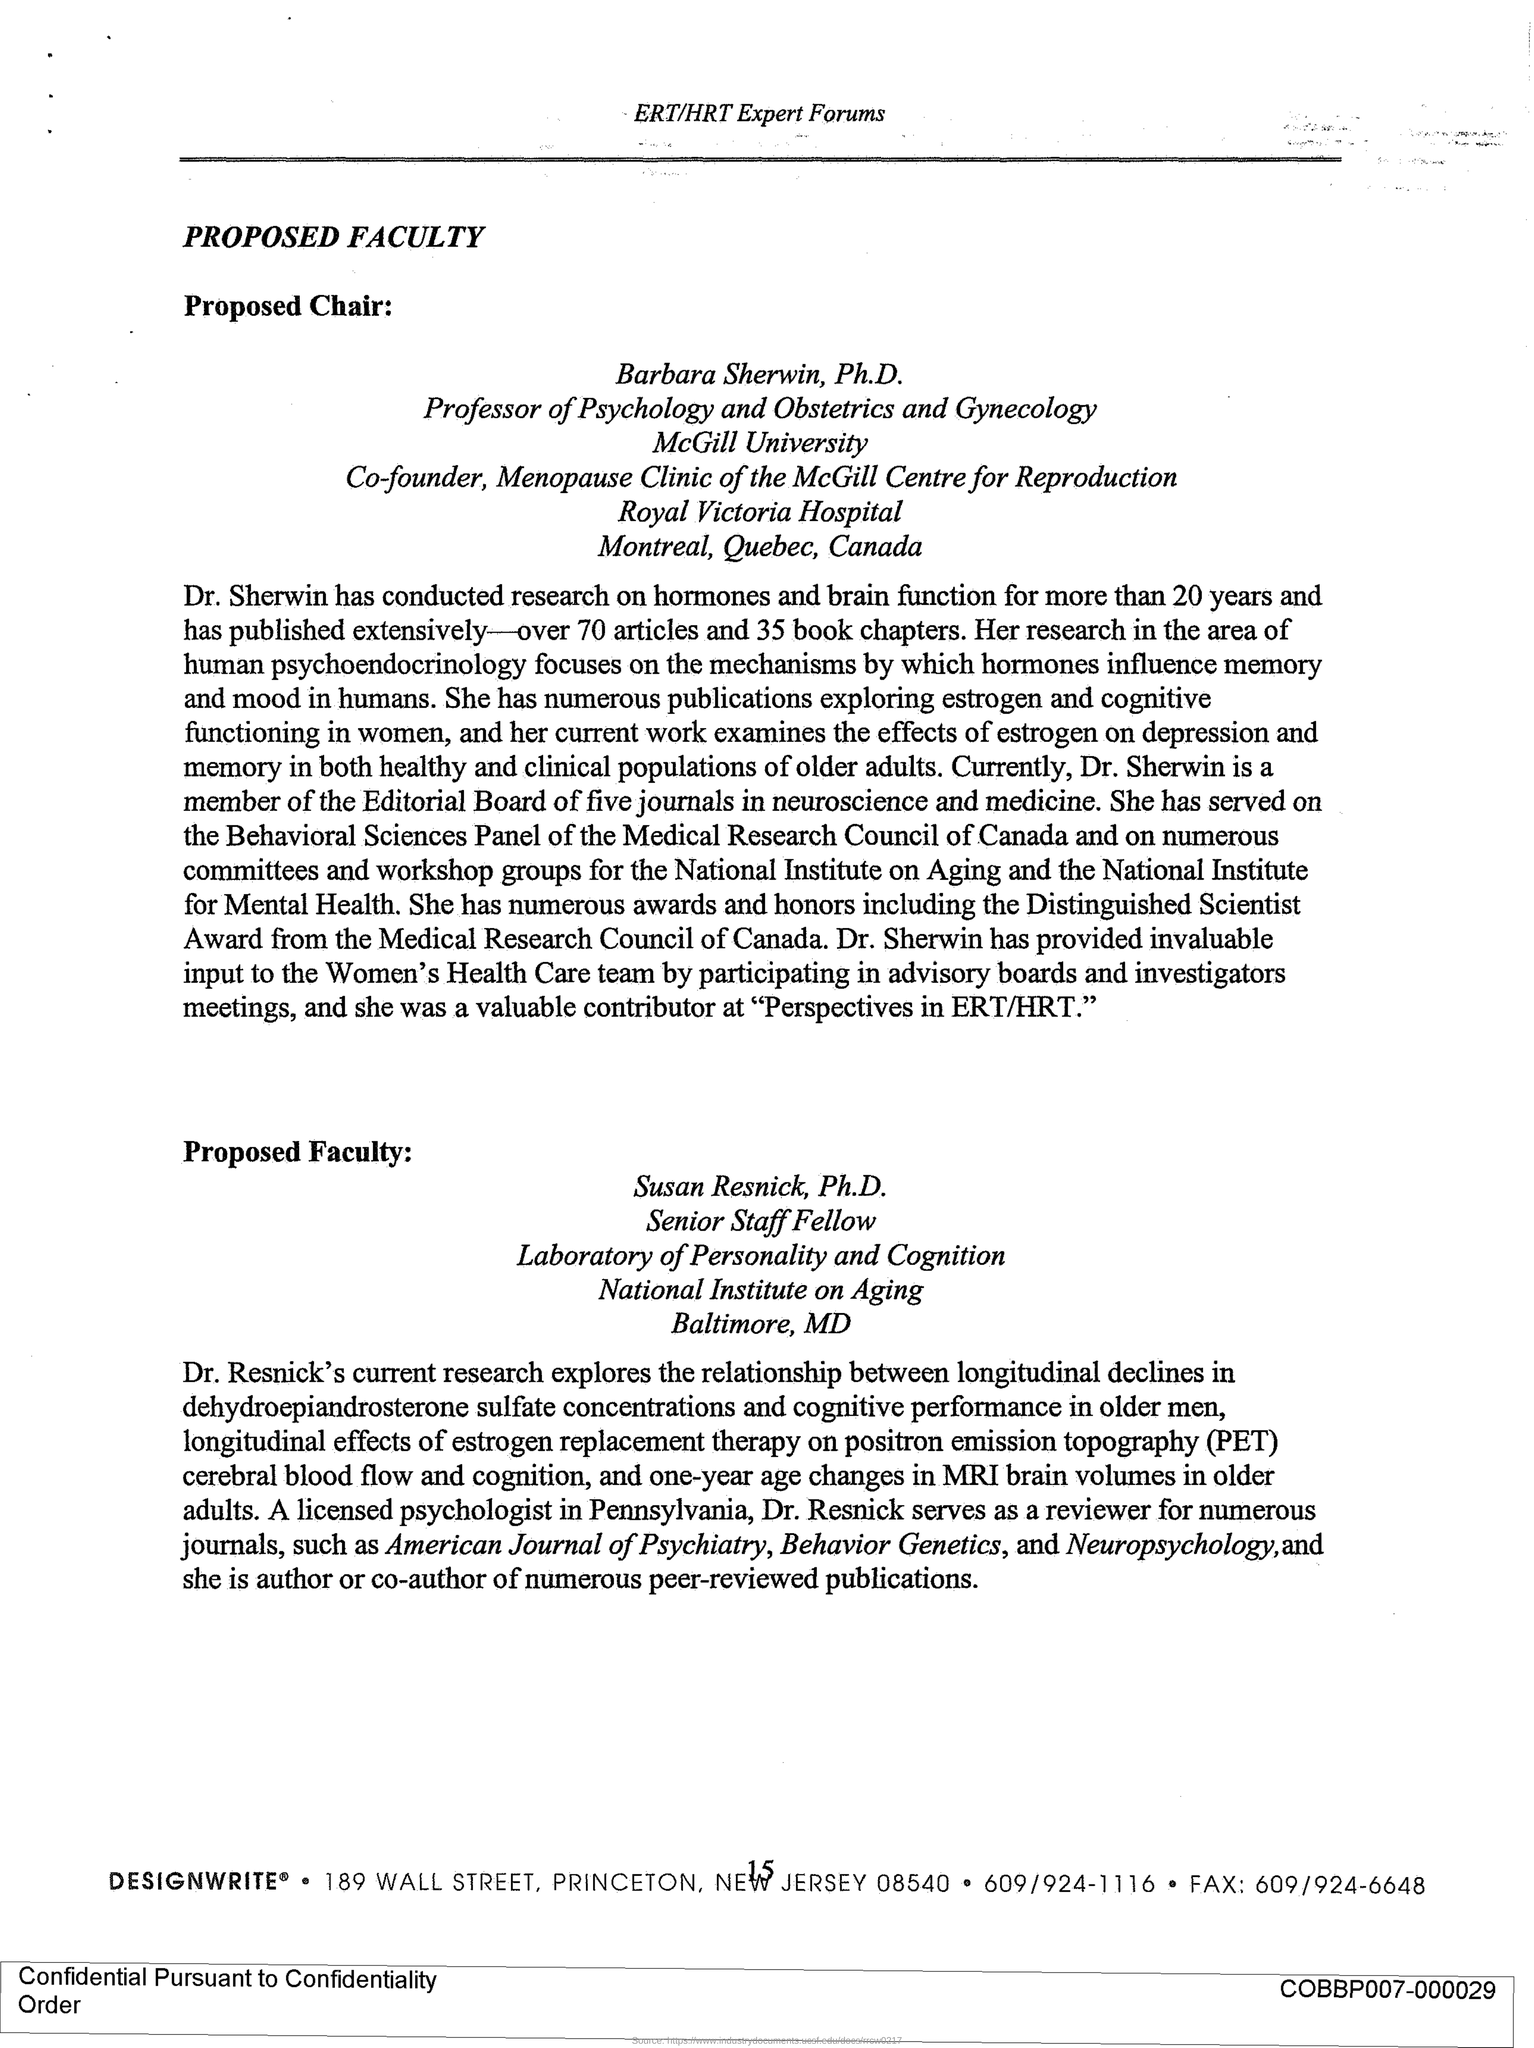What is the Title of the document?
Your answer should be very brief. PROPOSED FACULTY. How many book chapters has Dr. Sherwin published?
Provide a short and direct response. 35. Who is a member of editorialboard of five journals in neuroscience and medicine?
Offer a terse response. Dr. Sherwin. 